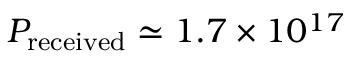Convert formula to latex. <formula><loc_0><loc_0><loc_500><loc_500>P _ { r e c e i v e d } \simeq 1 . 7 \times 1 0 ^ { 1 7 }</formula> 